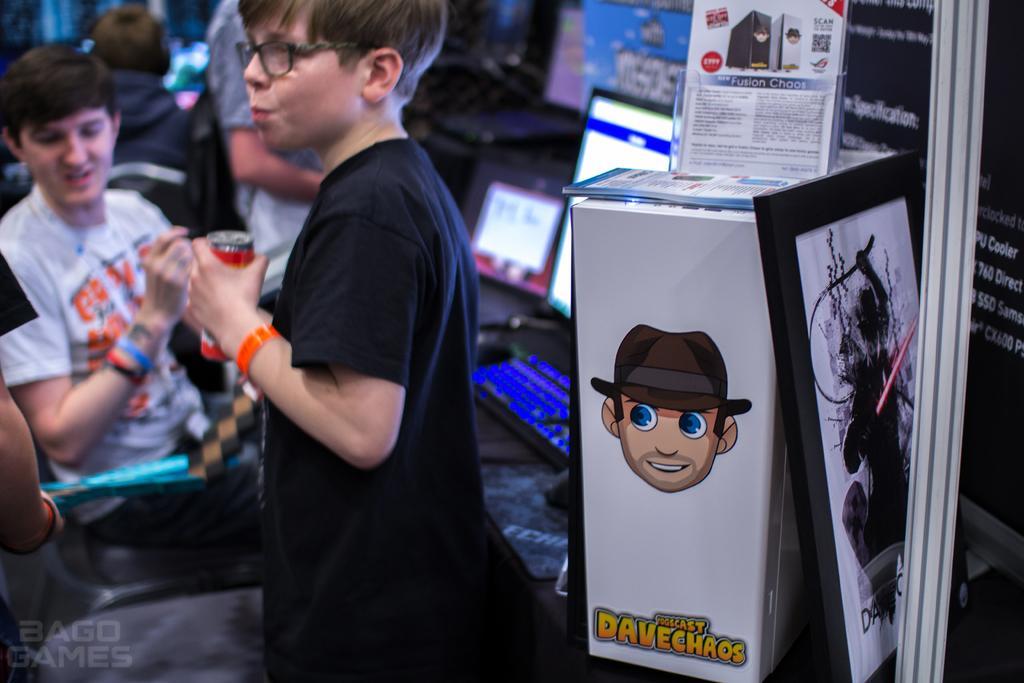In one or two sentences, can you explain what this image depicts? In this image we can see a boy wearing glasses and holding the tin. In the background we can see a few people. Image also consists of a monitor, keyboard, laptop, painting frame and also the CPU. On the left there is text. 